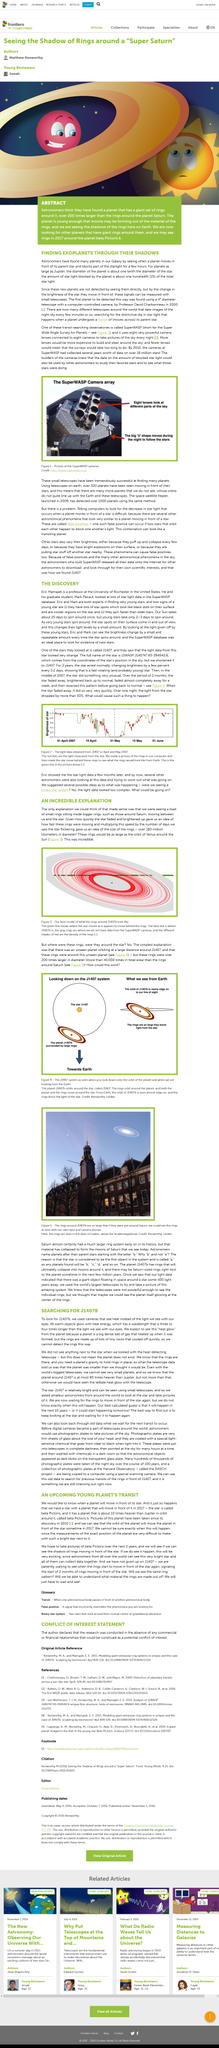Highlight a few significant elements in this photo. J1407b is the star that they are discussing. Astronomers have discovered many planets in our galaxy, making them the group of people responsible for this significant discovery. In the year 2017, it is anticipated that rings around the exoplanet Beta Pictoris b will become visible. Astronomers are able to locate planets as large as Jupiter by using the fact that the diameter of the planet is approximately one tenth the diameter of the star it orbits. The article's topic is J1407b. 